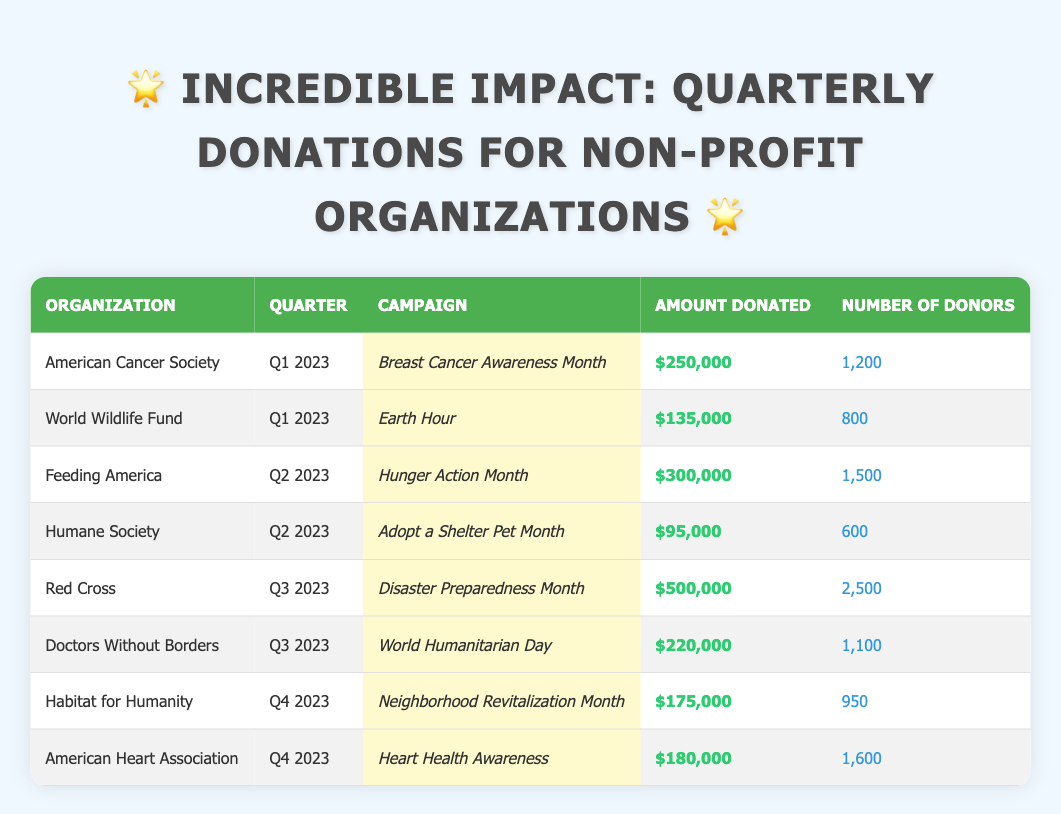What was the total amount donated in Q1 2023? In Q1 2023, the total amount donated includes the American Cancer Society's donation of $250,000 and the World Wildlife Fund's donation of $135,000. Therefore, the total is $250,000 + $135,000 = $385,000.
Answer: $385,000 Which organization received the highest donation amount in Q3 2023? In Q3 2023, the Red Cross had the highest donation amount of $500,000, as listed in the table.
Answer: Red Cross How many donors contributed to the American Heart Association's campaign? The American Heart Association had 1,600 donors contributing to its campaign, as indicated in the table.
Answer: 1,600 What is the average donation amount across all organizations for Q2 2023? In Q2 2023, Feeding America donated $300,000 and the Humane Society donated $95,000. The sum is $300,000 + $95,000 = $395,000. There are two organizations, so the average donation amount is $395,000 / 2 = $197,500.
Answer: $197,500 Did the Humane Society receive more than $100,000 in donations during Q2 2023? The Humane Society received $95,000 during Q2 2023, which is less than $100,000. Therefore, the statement is false.
Answer: No Which quarter had the least number of donors? By reviewing each quarter: Q1 2023 has 1,200 + 800 = 2,000 total donors, Q2 2023 has 1,500 + 600 = 2,100 total donors, Q3 2023 has 2,500 + 1,100 = 3,600 total donors, and Q4 2023 has 950 + 1,600 = 2,550 total donors. Q1 2023 had the least number of total donors at 2,000.
Answer: Q1 2023 What was the difference in the amount donated between the campaign for Disaster Preparedness Month and Hunger Action Month? The amount donated for Disaster Preparedness Month by the Red Cross was $500,000, and for Hunger Action Month by Feeding America, it was $300,000. The difference is $500,000 - $300,000 = $200,000.
Answer: $200,000 Is the total amount donated in Q4 2023 greater than the total amount donated in Q2 2023? In Q4 2023, the total amount is $175,000 + $180,000 = $355,000, while in Q2 2023, it is $300,000 + $95,000 = $395,000. Since $355,000 is less than $395,000, the statement is false.
Answer: No 